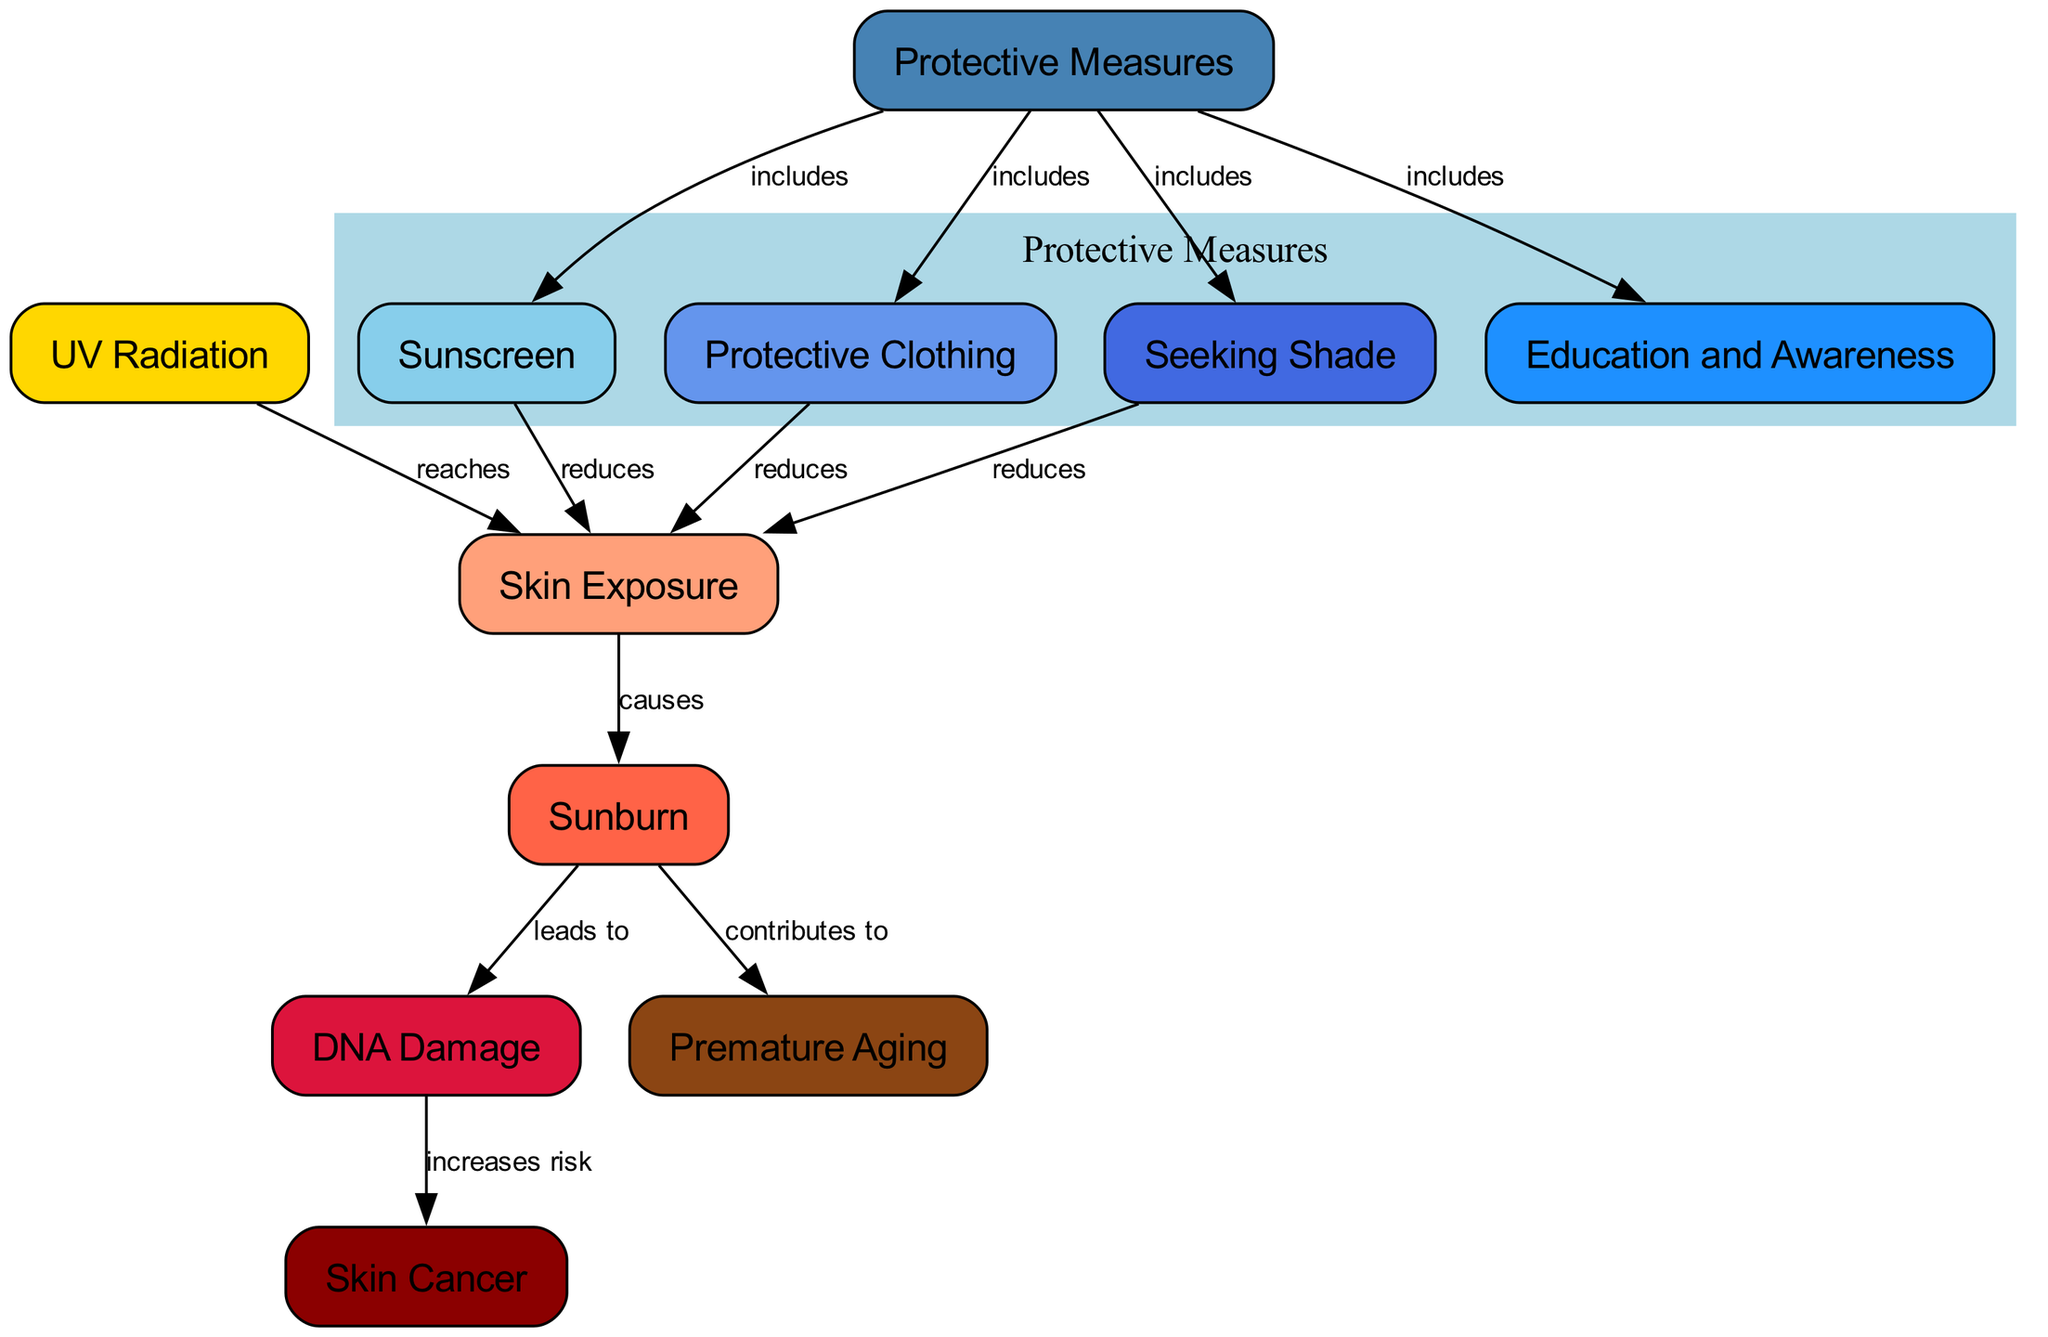What nodes are included in the diagram? The diagram includes the following nodes: UV Radiation, Skin Exposure, Sunburn, DNA Damage, Premature Aging, Skin Cancer, Protective Measures, Sunscreen, Clothing, Shade, and Education and Awareness. Each of these represents a key aspect of the impact of UV radiation on skin.
Answer: UV Radiation, Skin Exposure, Sunburn, DNA Damage, Premature Aging, Skin Cancer, Protective Measures, Sunscreen, Clothing, Shade, Education and Awareness Which node is affected first by UV radiation? The first node that is affected by UV radiation is Skin Exposure, as indicated by the edge that states UV Radiation reaches Skin Exposure. This is the initial interaction before further effects occur.
Answer: Skin Exposure What is the relationship between Sunburn and DNA Damage? The relationship is that Sunburn leads to DNA Damage, as specified by the edge connecting these two nodes. This implies that experiencing Sunburn has consequences for the skin's DNA integrity.
Answer: leads to How many protective measures are listed in the diagram? There are four protective measures listed in the diagram: Sunscreen, Protective Clothing, Shade, and Education and Awareness. These measures help reduce the impact of UV radiation on the skin.
Answer: 4 Which protective measure directly reduces Skin Exposure? All three protective measures—Sunscreen, Protective Clothing, and Shade—reduce Skin Exposure, as indicated by their edges connecting back to the Skin Exposure node. This shows their efficacy in minimizing skin damage.
Answer: Sunscreen, Protective Clothing, Shade What long-term effect does DNA Damage increase the risk of? DNA Damage increases the risk of Skin Cancer, which is shown by the edge leading from DNA Damage to Skin Cancer. This highlights a severe long-term consequence of repeated UV exposure.
Answer: Skin Cancer Which node connects to both Skin Cancer and Premature Aging through Sunburn? Sunburn connects to both DNA Damage, which leads to Skin Cancer, and also directly contributes to Premature Aging. This shows that Sunburn has multiple negative outcomes.
Answer: Sunburn Which protective measure is related to raising awareness about sun safety? Education and Awareness is the protective measure that pertains to raising awareness about the dangers of UV radiation and the importance of sun safety practices. This indicates a preventive strategy beyond physical barriers.
Answer: Education and Awareness 